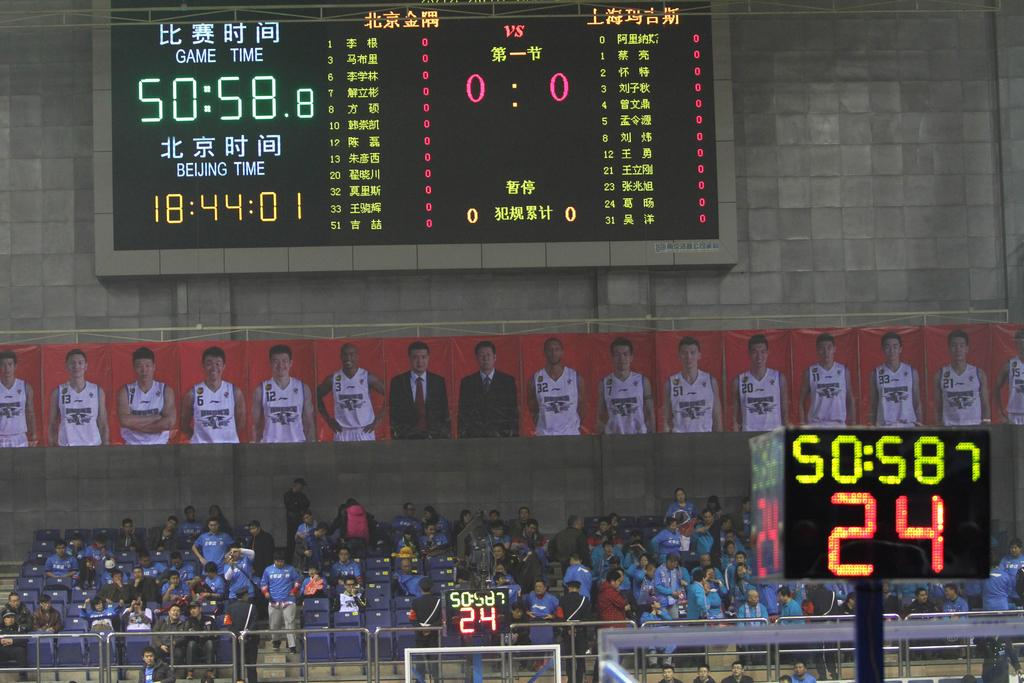<image>
Offer a succinct explanation of the picture presented. A crowd in a stand  under a scoreboard showing 50:58.8 until game time. 